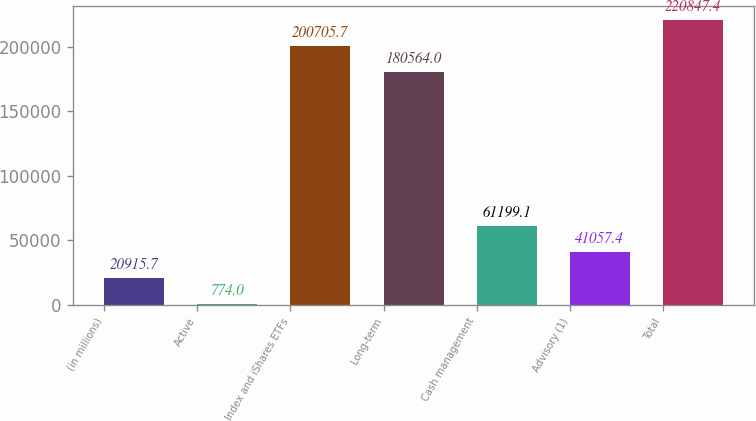Convert chart. <chart><loc_0><loc_0><loc_500><loc_500><bar_chart><fcel>(in millions)<fcel>Active<fcel>Index and iShares ETFs<fcel>Long-term<fcel>Cash management<fcel>Advisory (1)<fcel>Total<nl><fcel>20915.7<fcel>774<fcel>200706<fcel>180564<fcel>61199.1<fcel>41057.4<fcel>220847<nl></chart> 